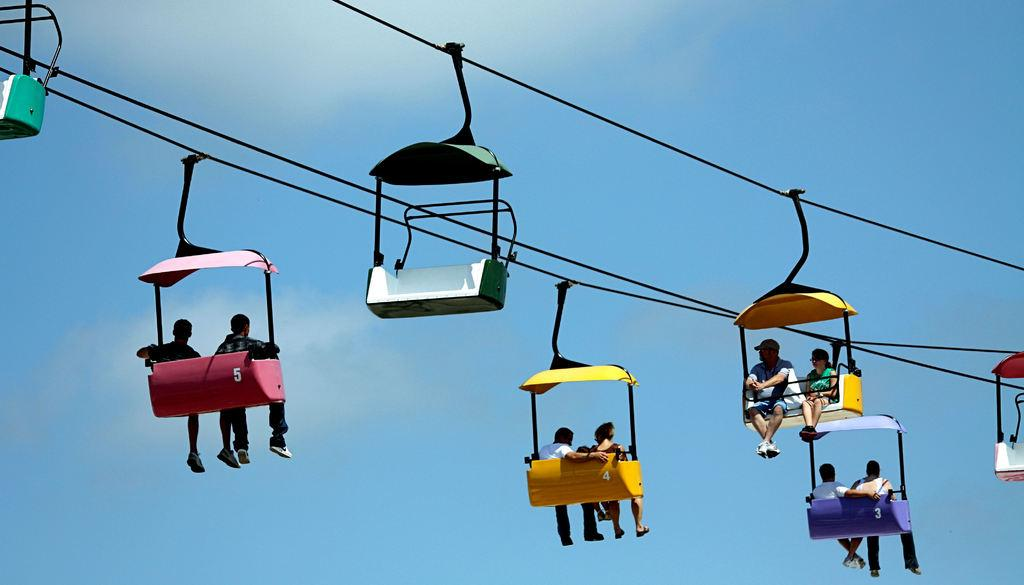What is the main subject of the image? The main subject of the image is a ropeway. Can you describe the ropeway in more detail? Yes, there is a ropeway in the center of the image. What are the people in the image doing? The people in the image are sitting in the ropeway cabins. What type of pencil is being used by the secretary in the image? There is no secretary or pencil present in the image; it features a ropeway with people sitting in the cabins. 